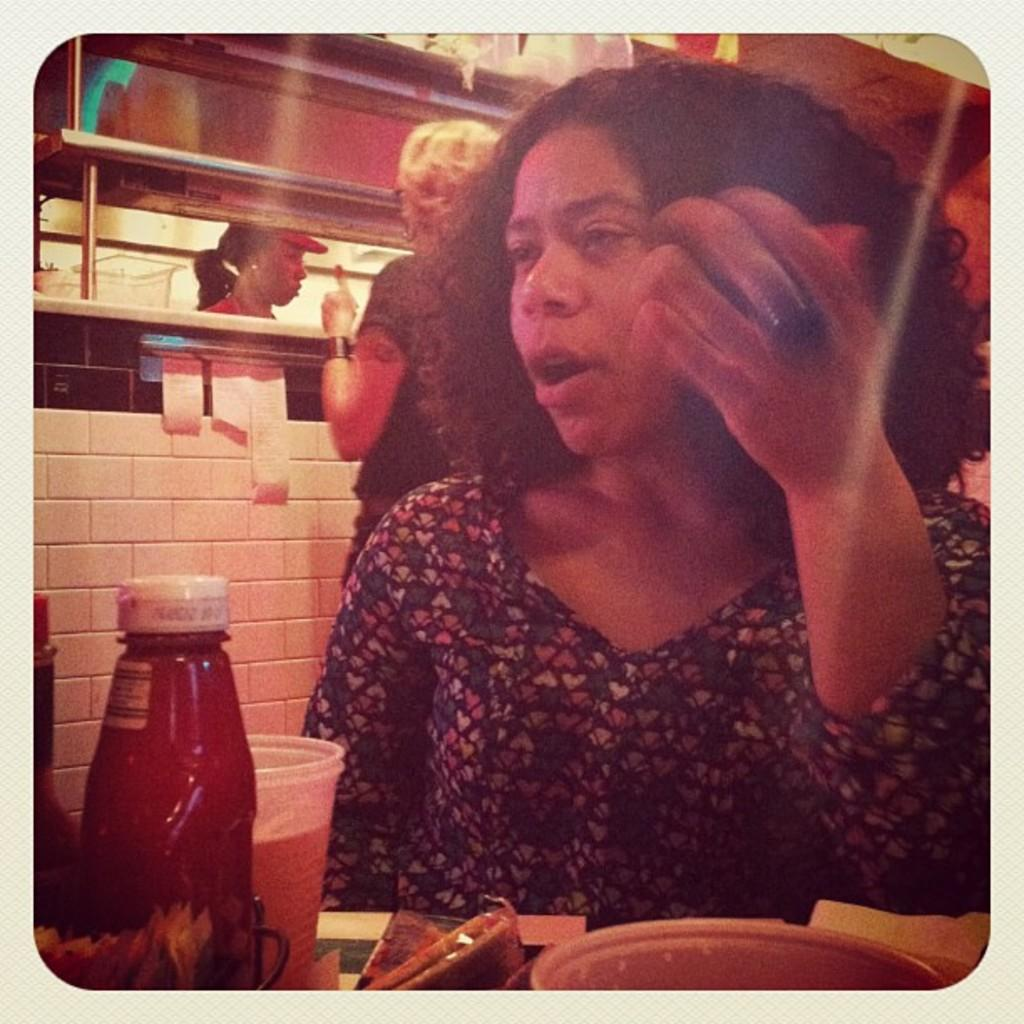Who is present in the image? There is a woman in the image. What objects can be seen in the image? There is a bottle, a glass, and a bowl in the image. What can be seen in the background of the image? There is a wall and people in the background of the image. How many geese are flying in the background of the image? There are no geese present in the image; only a wall and people can be seen in the background. 